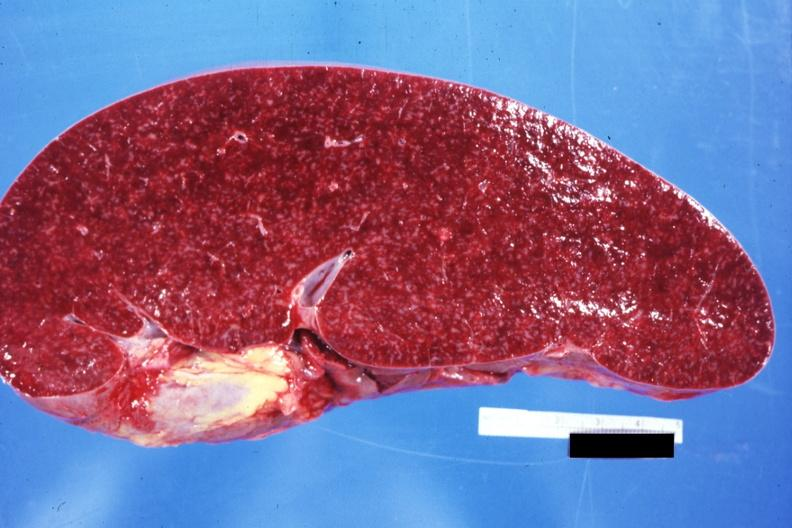what see other sides this case?
Answer the question using a single word or phrase. Normal 